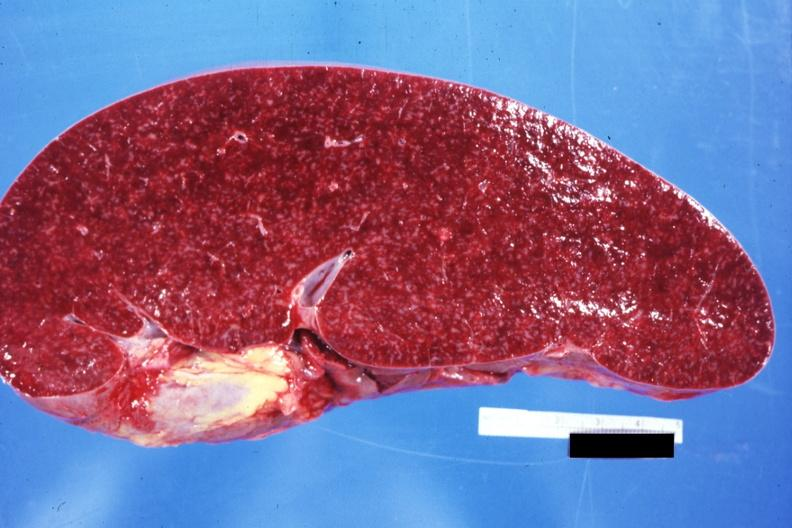what see other sides this case?
Answer the question using a single word or phrase. Normal 